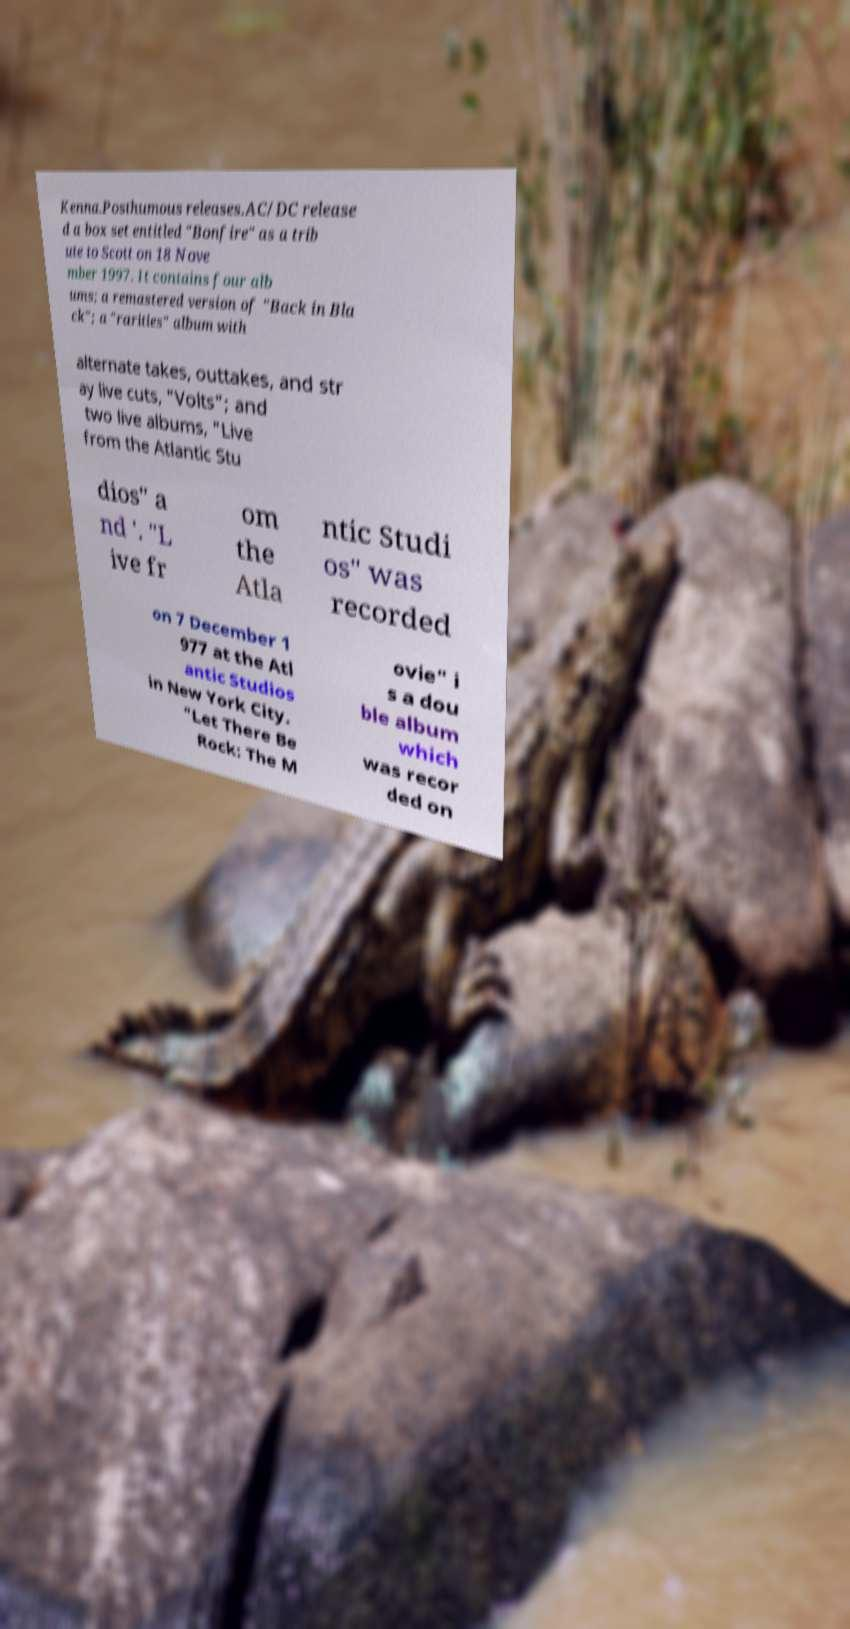I need the written content from this picture converted into text. Can you do that? Kenna.Posthumous releases.AC/DC release d a box set entitled "Bonfire" as a trib ute to Scott on 18 Nove mber 1997. It contains four alb ums; a remastered version of "Back in Bla ck"; a "rarities" album with alternate takes, outtakes, and str ay live cuts, "Volts"; and two live albums, "Live from the Atlantic Stu dios" a nd '. "L ive fr om the Atla ntic Studi os" was recorded on 7 December 1 977 at the Atl antic Studios in New York City. "Let There Be Rock: The M ovie" i s a dou ble album which was recor ded on 